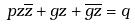<formula> <loc_0><loc_0><loc_500><loc_500>p z \overline { z } + g z + \overline { g z } = q</formula> 